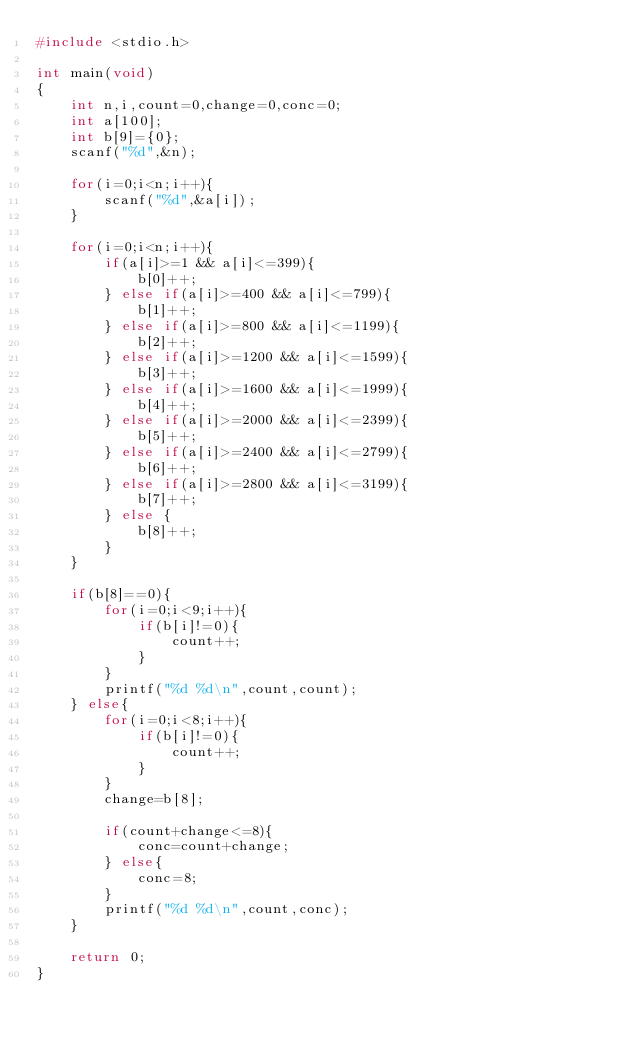<code> <loc_0><loc_0><loc_500><loc_500><_C_>#include <stdio.h>

int main(void)
{
	int n,i,count=0,change=0,conc=0;
	int a[100];
	int b[9]={0};
	scanf("%d",&n);
	
	for(i=0;i<n;i++){
		scanf("%d",&a[i]);
	}
	
	for(i=0;i<n;i++){
		if(a[i]>=1 && a[i]<=399){
			b[0]++;
		} else if(a[i]>=400 && a[i]<=799){
			b[1]++;
		} else if(a[i]>=800 && a[i]<=1199){
			b[2]++;
		} else if(a[i]>=1200 && a[i]<=1599){
			b[3]++;
		} else if(a[i]>=1600 && a[i]<=1999){
			b[4]++;
		} else if(a[i]>=2000 && a[i]<=2399){
			b[5]++;
		} else if(a[i]>=2400 && a[i]<=2799){
			b[6]++;
		} else if(a[i]>=2800 && a[i]<=3199){
			b[7]++;
		} else {
			b[8]++;
		}
	}
	
	if(b[8]==0){
		for(i=0;i<9;i++){
			if(b[i]!=0){
				count++;
			}
		}
		printf("%d %d\n",count,count);
	} else{
		for(i=0;i<8;i++){
			if(b[i]!=0){
				count++;
			}
		}
		change=b[8];
		
		if(count+change<=8){
			conc=count+change;
		} else{
			conc=8;
		}
		printf("%d %d\n",count,conc);
	}
			
	return 0;
}</code> 